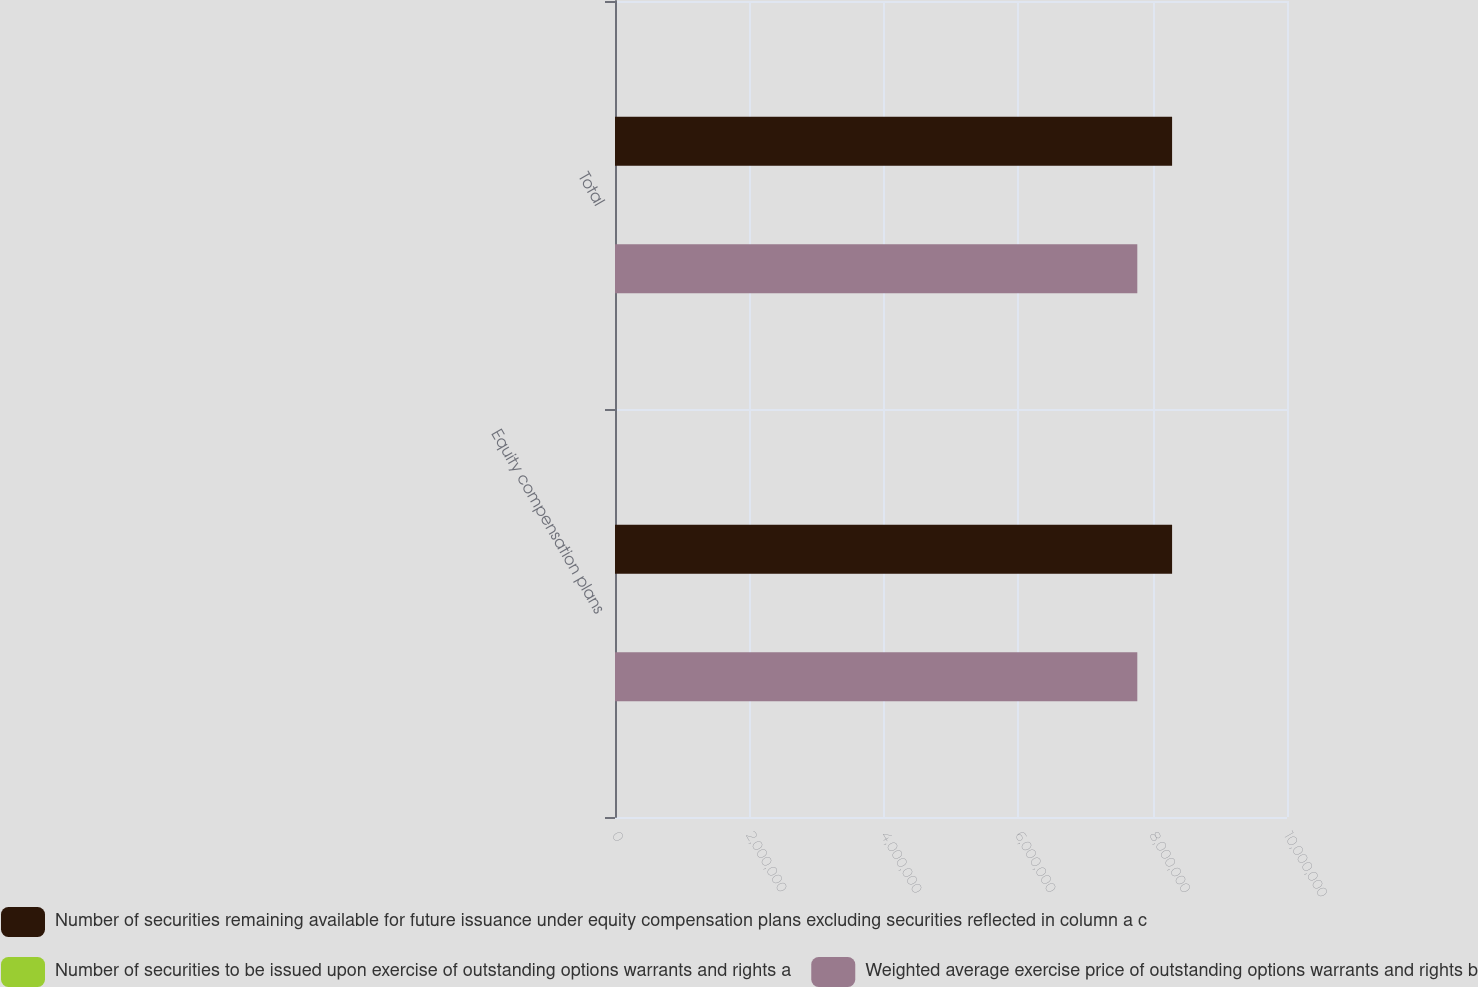<chart> <loc_0><loc_0><loc_500><loc_500><stacked_bar_chart><ecel><fcel>Equity compensation plans<fcel>Total<nl><fcel>Number of securities remaining available for future issuance under equity compensation plans excluding securities reflected in column a c<fcel>8.28995e+06<fcel>8.28995e+06<nl><fcel>Number of securities to be issued upon exercise of outstanding options warrants and rights a<fcel>60.28<fcel>60.28<nl><fcel>Weighted average exercise price of outstanding options warrants and rights b<fcel>7.77248e+06<fcel>7.77248e+06<nl></chart> 